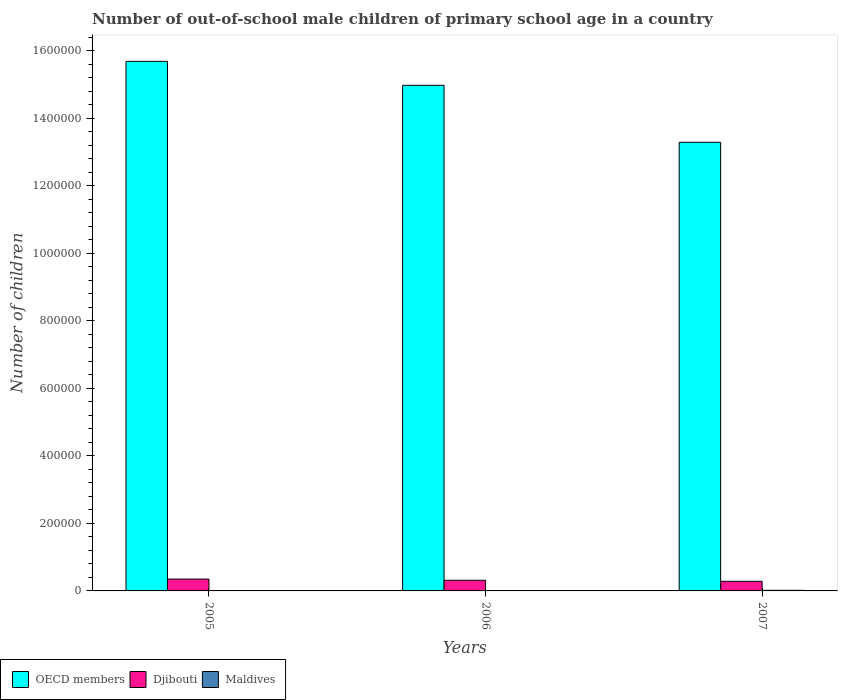How many groups of bars are there?
Provide a short and direct response. 3. Are the number of bars per tick equal to the number of legend labels?
Offer a very short reply. Yes. How many bars are there on the 2nd tick from the left?
Provide a short and direct response. 3. In how many cases, is the number of bars for a given year not equal to the number of legend labels?
Offer a very short reply. 0. What is the number of out-of-school male children in OECD members in 2007?
Ensure brevity in your answer.  1.33e+06. Across all years, what is the maximum number of out-of-school male children in Djibouti?
Your answer should be compact. 3.50e+04. Across all years, what is the minimum number of out-of-school male children in Djibouti?
Provide a short and direct response. 2.85e+04. In which year was the number of out-of-school male children in Maldives minimum?
Keep it short and to the point. 2005. What is the total number of out-of-school male children in Djibouti in the graph?
Give a very brief answer. 9.51e+04. What is the difference between the number of out-of-school male children in Maldives in 2006 and that in 2007?
Give a very brief answer. -1187. What is the difference between the number of out-of-school male children in OECD members in 2005 and the number of out-of-school male children in Maldives in 2006?
Your answer should be very brief. 1.57e+06. What is the average number of out-of-school male children in Maldives per year?
Your answer should be compact. 990. In the year 2006, what is the difference between the number of out-of-school male children in OECD members and number of out-of-school male children in Maldives?
Make the answer very short. 1.50e+06. What is the ratio of the number of out-of-school male children in OECD members in 2005 to that in 2007?
Your answer should be compact. 1.18. Is the difference between the number of out-of-school male children in OECD members in 2005 and 2006 greater than the difference between the number of out-of-school male children in Maldives in 2005 and 2006?
Offer a terse response. Yes. What is the difference between the highest and the second highest number of out-of-school male children in Djibouti?
Give a very brief answer. 3467. What is the difference between the highest and the lowest number of out-of-school male children in Maldives?
Offer a very short reply. 1192. Is the sum of the number of out-of-school male children in Djibouti in 2005 and 2007 greater than the maximum number of out-of-school male children in Maldives across all years?
Offer a terse response. Yes. What does the 1st bar from the left in 2007 represents?
Your response must be concise. OECD members. What does the 1st bar from the right in 2005 represents?
Provide a short and direct response. Maldives. Is it the case that in every year, the sum of the number of out-of-school male children in Maldives and number of out-of-school male children in OECD members is greater than the number of out-of-school male children in Djibouti?
Ensure brevity in your answer.  Yes. How many bars are there?
Make the answer very short. 9. Are all the bars in the graph horizontal?
Keep it short and to the point. No. What is the difference between two consecutive major ticks on the Y-axis?
Your answer should be very brief. 2.00e+05. Are the values on the major ticks of Y-axis written in scientific E-notation?
Keep it short and to the point. No. Does the graph contain grids?
Provide a succinct answer. No. How many legend labels are there?
Provide a succinct answer. 3. What is the title of the graph?
Keep it short and to the point. Number of out-of-school male children of primary school age in a country. Does "Zimbabwe" appear as one of the legend labels in the graph?
Your response must be concise. No. What is the label or title of the Y-axis?
Keep it short and to the point. Number of children. What is the Number of children in OECD members in 2005?
Keep it short and to the point. 1.57e+06. What is the Number of children of Djibouti in 2005?
Offer a terse response. 3.50e+04. What is the Number of children in Maldives in 2005?
Give a very brief answer. 591. What is the Number of children in OECD members in 2006?
Give a very brief answer. 1.50e+06. What is the Number of children of Djibouti in 2006?
Offer a very short reply. 3.16e+04. What is the Number of children of Maldives in 2006?
Your answer should be compact. 596. What is the Number of children in OECD members in 2007?
Provide a succinct answer. 1.33e+06. What is the Number of children in Djibouti in 2007?
Give a very brief answer. 2.85e+04. What is the Number of children in Maldives in 2007?
Keep it short and to the point. 1783. Across all years, what is the maximum Number of children of OECD members?
Ensure brevity in your answer.  1.57e+06. Across all years, what is the maximum Number of children in Djibouti?
Ensure brevity in your answer.  3.50e+04. Across all years, what is the maximum Number of children in Maldives?
Make the answer very short. 1783. Across all years, what is the minimum Number of children of OECD members?
Offer a very short reply. 1.33e+06. Across all years, what is the minimum Number of children in Djibouti?
Keep it short and to the point. 2.85e+04. Across all years, what is the minimum Number of children in Maldives?
Offer a very short reply. 591. What is the total Number of children of OECD members in the graph?
Keep it short and to the point. 4.39e+06. What is the total Number of children of Djibouti in the graph?
Ensure brevity in your answer.  9.51e+04. What is the total Number of children in Maldives in the graph?
Give a very brief answer. 2970. What is the difference between the Number of children in OECD members in 2005 and that in 2006?
Your response must be concise. 7.10e+04. What is the difference between the Number of children of Djibouti in 2005 and that in 2006?
Offer a very short reply. 3467. What is the difference between the Number of children of OECD members in 2005 and that in 2007?
Your answer should be compact. 2.40e+05. What is the difference between the Number of children of Djibouti in 2005 and that in 2007?
Offer a very short reply. 6553. What is the difference between the Number of children of Maldives in 2005 and that in 2007?
Provide a short and direct response. -1192. What is the difference between the Number of children in OECD members in 2006 and that in 2007?
Provide a succinct answer. 1.69e+05. What is the difference between the Number of children in Djibouti in 2006 and that in 2007?
Give a very brief answer. 3086. What is the difference between the Number of children of Maldives in 2006 and that in 2007?
Offer a very short reply. -1187. What is the difference between the Number of children of OECD members in 2005 and the Number of children of Djibouti in 2006?
Provide a short and direct response. 1.54e+06. What is the difference between the Number of children of OECD members in 2005 and the Number of children of Maldives in 2006?
Offer a terse response. 1.57e+06. What is the difference between the Number of children of Djibouti in 2005 and the Number of children of Maldives in 2006?
Your answer should be compact. 3.45e+04. What is the difference between the Number of children in OECD members in 2005 and the Number of children in Djibouti in 2007?
Your answer should be compact. 1.54e+06. What is the difference between the Number of children in OECD members in 2005 and the Number of children in Maldives in 2007?
Your response must be concise. 1.57e+06. What is the difference between the Number of children of Djibouti in 2005 and the Number of children of Maldives in 2007?
Your response must be concise. 3.33e+04. What is the difference between the Number of children in OECD members in 2006 and the Number of children in Djibouti in 2007?
Keep it short and to the point. 1.47e+06. What is the difference between the Number of children in OECD members in 2006 and the Number of children in Maldives in 2007?
Offer a terse response. 1.50e+06. What is the difference between the Number of children in Djibouti in 2006 and the Number of children in Maldives in 2007?
Keep it short and to the point. 2.98e+04. What is the average Number of children of OECD members per year?
Offer a terse response. 1.46e+06. What is the average Number of children of Djibouti per year?
Offer a very short reply. 3.17e+04. What is the average Number of children of Maldives per year?
Ensure brevity in your answer.  990. In the year 2005, what is the difference between the Number of children of OECD members and Number of children of Djibouti?
Provide a short and direct response. 1.53e+06. In the year 2005, what is the difference between the Number of children in OECD members and Number of children in Maldives?
Provide a short and direct response. 1.57e+06. In the year 2005, what is the difference between the Number of children of Djibouti and Number of children of Maldives?
Offer a very short reply. 3.45e+04. In the year 2006, what is the difference between the Number of children in OECD members and Number of children in Djibouti?
Ensure brevity in your answer.  1.47e+06. In the year 2006, what is the difference between the Number of children of OECD members and Number of children of Maldives?
Give a very brief answer. 1.50e+06. In the year 2006, what is the difference between the Number of children in Djibouti and Number of children in Maldives?
Your answer should be compact. 3.10e+04. In the year 2007, what is the difference between the Number of children in OECD members and Number of children in Djibouti?
Offer a terse response. 1.30e+06. In the year 2007, what is the difference between the Number of children in OECD members and Number of children in Maldives?
Keep it short and to the point. 1.33e+06. In the year 2007, what is the difference between the Number of children in Djibouti and Number of children in Maldives?
Provide a short and direct response. 2.67e+04. What is the ratio of the Number of children of OECD members in 2005 to that in 2006?
Your answer should be very brief. 1.05. What is the ratio of the Number of children of Djibouti in 2005 to that in 2006?
Offer a very short reply. 1.11. What is the ratio of the Number of children in Maldives in 2005 to that in 2006?
Offer a very short reply. 0.99. What is the ratio of the Number of children of OECD members in 2005 to that in 2007?
Offer a terse response. 1.18. What is the ratio of the Number of children in Djibouti in 2005 to that in 2007?
Keep it short and to the point. 1.23. What is the ratio of the Number of children in Maldives in 2005 to that in 2007?
Ensure brevity in your answer.  0.33. What is the ratio of the Number of children in OECD members in 2006 to that in 2007?
Your answer should be compact. 1.13. What is the ratio of the Number of children of Djibouti in 2006 to that in 2007?
Your response must be concise. 1.11. What is the ratio of the Number of children in Maldives in 2006 to that in 2007?
Offer a terse response. 0.33. What is the difference between the highest and the second highest Number of children in OECD members?
Make the answer very short. 7.10e+04. What is the difference between the highest and the second highest Number of children in Djibouti?
Ensure brevity in your answer.  3467. What is the difference between the highest and the second highest Number of children in Maldives?
Make the answer very short. 1187. What is the difference between the highest and the lowest Number of children in OECD members?
Provide a succinct answer. 2.40e+05. What is the difference between the highest and the lowest Number of children of Djibouti?
Provide a short and direct response. 6553. What is the difference between the highest and the lowest Number of children in Maldives?
Offer a terse response. 1192. 